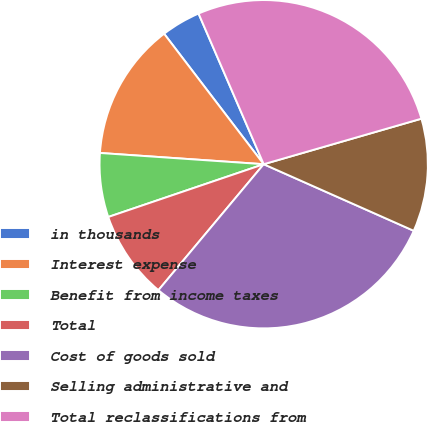Convert chart. <chart><loc_0><loc_0><loc_500><loc_500><pie_chart><fcel>in thousands<fcel>Interest expense<fcel>Benefit from income taxes<fcel>Total<fcel>Cost of goods sold<fcel>Selling administrative and<fcel>Total reclassifications from<nl><fcel>3.88%<fcel>13.53%<fcel>6.3%<fcel>8.71%<fcel>29.43%<fcel>11.12%<fcel>27.02%<nl></chart> 